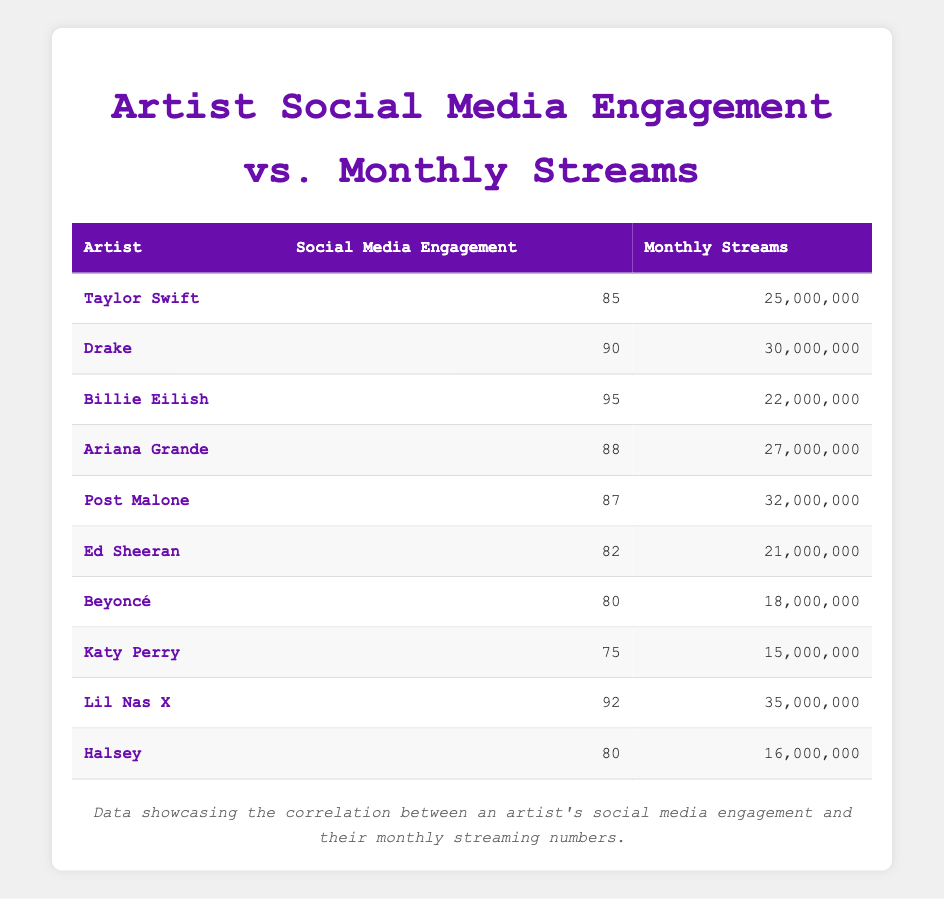What is the highest social media engagement score in the table? The highest social media engagement score can be found by looking at the engagement column. Scanning through the values, 95 (Billie Eilish) is the highest.
Answer: 95 What is the total monthly streams for all the artists combined? To find the total, we add each artist's monthly streams: (25000000 + 30000000 + 22000000 + 27000000 + 32000000 + 21000000 + 18000000 + 15000000 + 35000000 + 16000000) = 2,32000000.
Answer: 232000000 Which artist has the lowest monthly streams? By examining the monthly streams column, we see that Katy Perry has the lowest value at 15000000.
Answer: Katy Perry Is it true that all artists with social media engagement above 85 have monthly streams above 20 million? Checking the engagement column, we see that the artists with engagement above 85 include Taylor Swift (25M), Drake (30M), Billie Eilish (22M), Ariana Grande (27M), Post Malone (32M), and Lil Nas X (35M). All these artists have monthly streams above 20 million, making the statement true.
Answer: Yes What is the average social media engagement for artists with monthly streams greater than 25 million? First, identify the artists with monthly streams greater than 25 million: Drake (30M), Ariana Grande (27M), Post Malone (32M), and Lil Nas X (35M). Their engagements are: 90, 88, 87, and 92. The average is (90 + 88 + 87 + 92) / 4 = 89.25. Thus, the average engagement is 89.25.
Answer: 89.25 Which artist has a higher social media engagement, Beyoncé or Ed Sheeran? Looking at the engagement scores, Beyoncé has 80 and Ed Sheeran has 82. Since 82 is greater than 80, Ed Sheeran has a higher engagement score.
Answer: Ed Sheeran Can we say that higher social media engagement correlates with higher monthly streams based on this data? To analyze this, we should note that the majority of artists with higher engagement (88 and above) have higher monthly streams (25 million and above), except for Billie Eilish who has a lower stream count despite high engagement. Thus, there is a trend but not a definitive correlation.
Answer: No How many artists have social media engagement scores that fall below the average engagement score? The average engagement score is (85 + 90 + 95 + 88 + 87 + 82 + 80 + 75 + 92 + 80) / 10 = 84.5. The artists with scores below this average are: Ed Sheeran, Beyoncé, and Katy Perry. So, there are three artists below the average engagement.
Answer: 3 